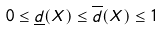<formula> <loc_0><loc_0><loc_500><loc_500>0 \leq \underline { d } ( X ) \leq \overline { d } ( X ) \leq 1</formula> 